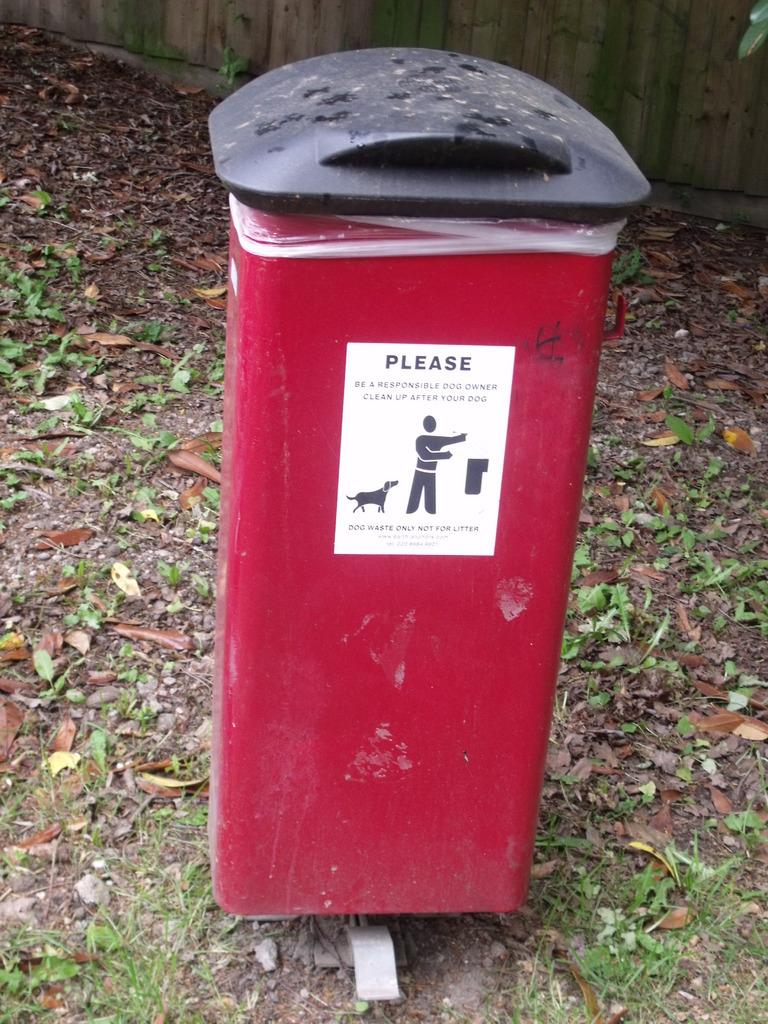Provide a one-sentence caption for the provided image. The red trash can with the black lid has a sticker that says PLEASE BE A RESPONSIBLE DOG CLEAN UP AFTER YOUR DOG. 